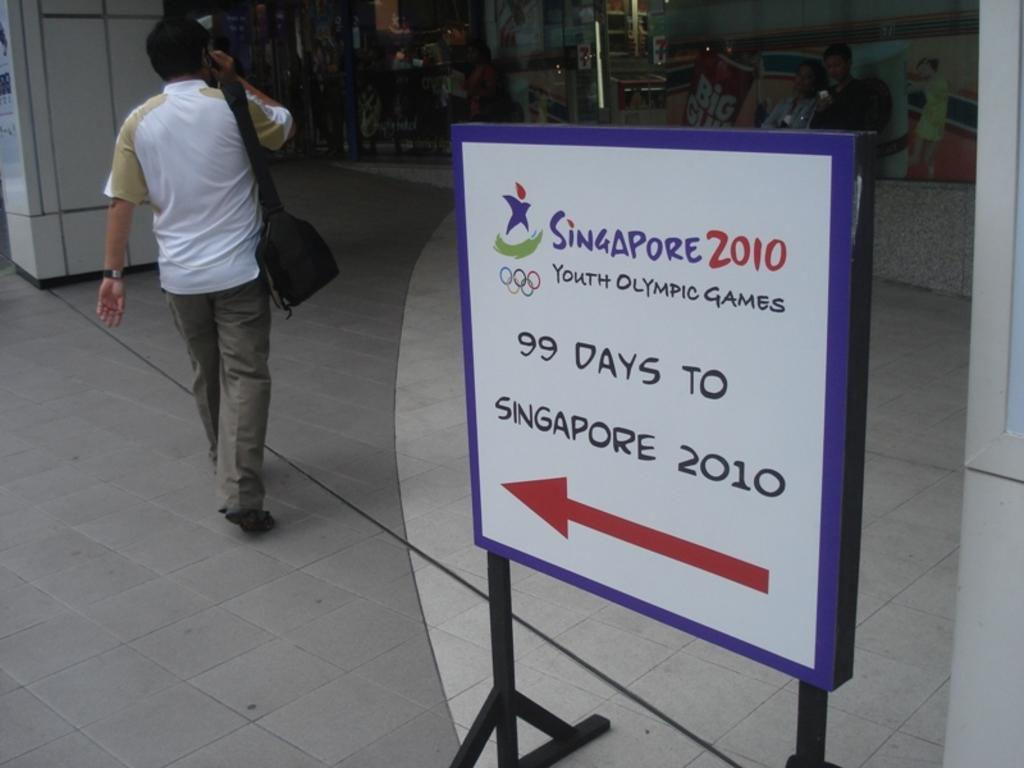What is the person in the image doing? There is a person walking in the image. What is the person holding while walking? The person is holding a bag. Can you describe the background of the image? There are objects in the background of the image. What type of string is the carpenter using to fix the faucet in the image? There is no carpenter, faucet, or string present in the image. 